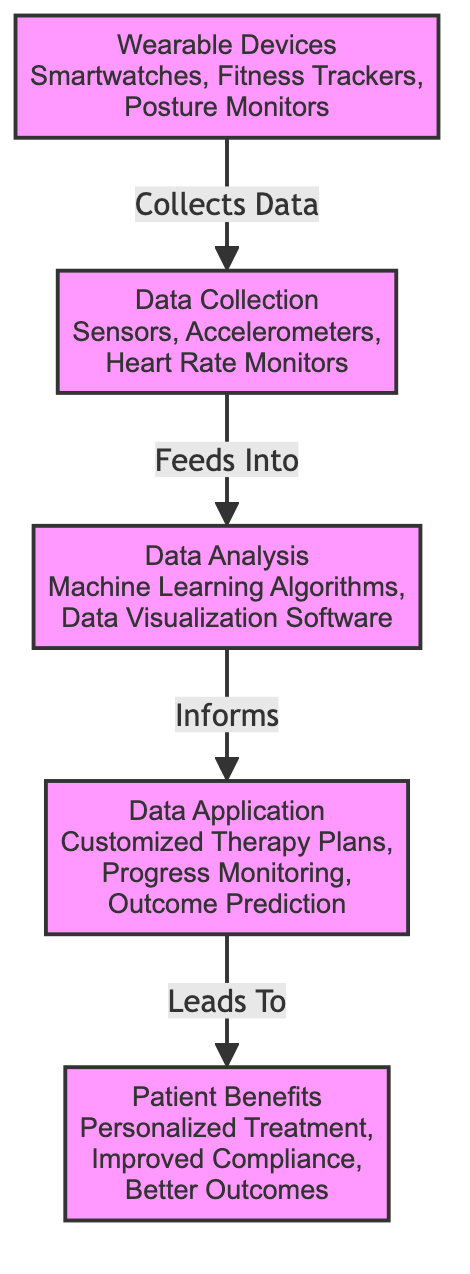What types of wearable devices are mentioned? The diagram lists "Smartwatches, Fitness Trackers, Posture Monitors" under the node for wearable devices, indicating these are the types discussed.
Answer: Smartwatches, Fitness Trackers, Posture Monitors How many main nodes are present in the diagram? The diagram includes five main nodes: Wearable Devices, Data Collection, Data Analysis, Data Application, and Patient Benefits. Counting these nodes results in a total of five.
Answer: Five What role does data collection play in this diagram? Data Collection is shown as a process that occurs after Wearable Devices; it collects data using sensors and other technologies, which then feeds into Data Analysis.
Answer: Collects data How does Data Analysis inform the next node? Data Analysis uses machine learning algorithms and data visualization software, and the information generated from this analysis directly informs the creation of Customized Therapy Plans in Data Application.
Answer: Informs What patient benefits result from the integration of this technology? The diagram specifies that the integration leads to "Personalized Treatment, Improved Compliance, Better Outcomes," indicating these are the benefits for patients.
Answer: Personalized Treatment, Improved Compliance, Better Outcomes What is the relationship between Data Collection and Wearable Devices? Data Collection is a process that is directly fed by the data collected from Wearable Devices, illustrating a flow from the devices to the collection of their data.
Answer: Collects data How many types of analyses are conducted in the Data Analysis stage? The Data Analysis stage specifically mentions "Machine Learning Algorithms" and "Data Visualization Software," indicating that there are two distinct types of analyses conducted here.
Answer: Two What does Data Application lead to? According to the flow, Data Application leads to Patient Benefits, signifying that the applications of analyzed data culminate in improved outcomes for patients.
Answer: Patient Benefits What is the primary purpose of wearable devices in this diagram? The primary purpose of wearable devices is to collect data that will facilitate the subsequent stages of analysis and application in physical therapy settings.
Answer: Collect data 